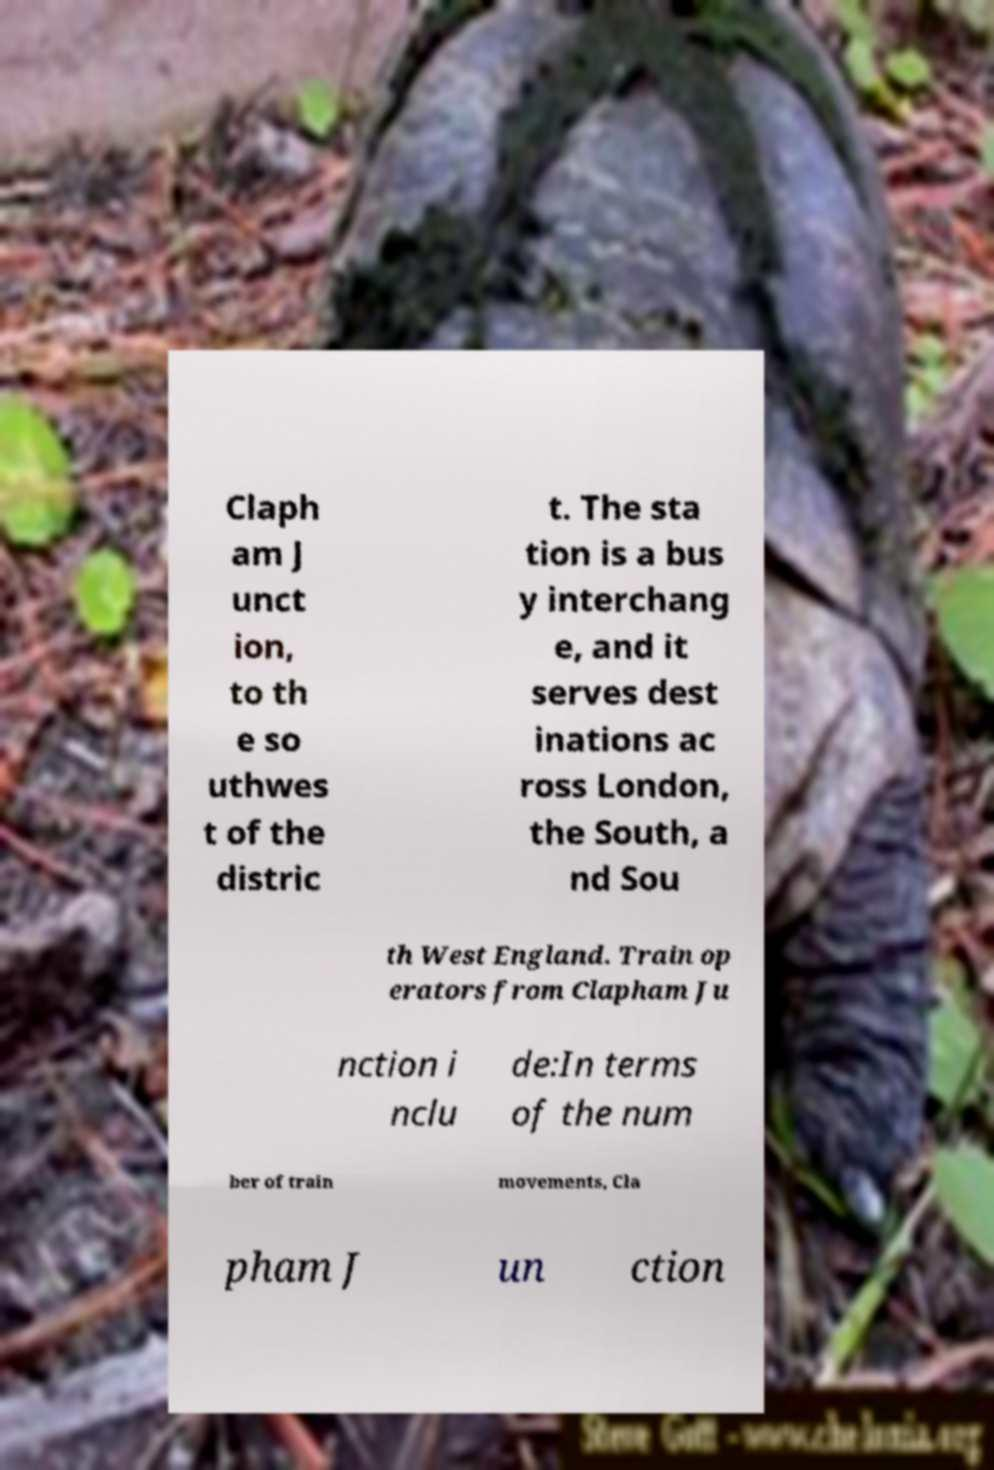There's text embedded in this image that I need extracted. Can you transcribe it verbatim? Claph am J unct ion, to th e so uthwes t of the distric t. The sta tion is a bus y interchang e, and it serves dest inations ac ross London, the South, a nd Sou th West England. Train op erators from Clapham Ju nction i nclu de:In terms of the num ber of train movements, Cla pham J un ction 